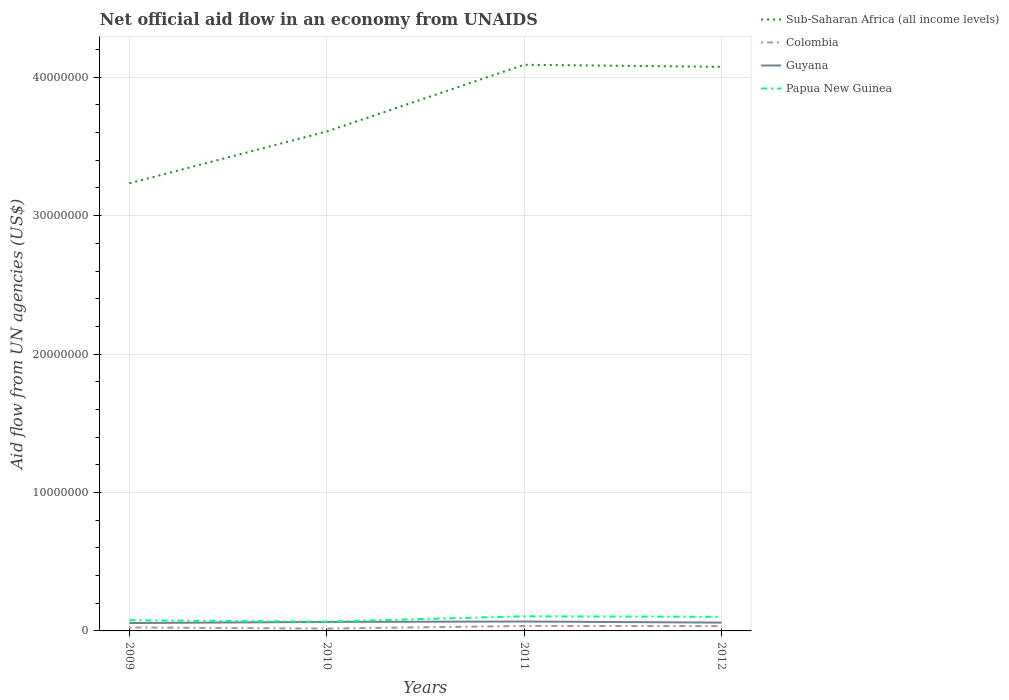Does the line corresponding to Sub-Saharan Africa (all income levels) intersect with the line corresponding to Guyana?
Offer a terse response. No. Is the number of lines equal to the number of legend labels?
Offer a very short reply. Yes. Across all years, what is the maximum net official aid flow in Guyana?
Ensure brevity in your answer.  5.70e+05. What is the total net official aid flow in Sub-Saharan Africa (all income levels) in the graph?
Your answer should be compact. 1.50e+05. What is the difference between the highest and the second highest net official aid flow in Sub-Saharan Africa (all income levels)?
Keep it short and to the point. 8.56e+06. What is the difference between the highest and the lowest net official aid flow in Colombia?
Your response must be concise. 2. Is the net official aid flow in Colombia strictly greater than the net official aid flow in Papua New Guinea over the years?
Provide a succinct answer. Yes. How many lines are there?
Provide a short and direct response. 4. How many years are there in the graph?
Provide a short and direct response. 4. Does the graph contain any zero values?
Provide a succinct answer. No. How are the legend labels stacked?
Keep it short and to the point. Vertical. What is the title of the graph?
Give a very brief answer. Net official aid flow in an economy from UNAIDS. What is the label or title of the Y-axis?
Provide a succinct answer. Aid flow from UN agencies (US$). What is the Aid flow from UN agencies (US$) in Sub-Saharan Africa (all income levels) in 2009?
Your answer should be compact. 3.23e+07. What is the Aid flow from UN agencies (US$) of Colombia in 2009?
Provide a short and direct response. 2.50e+05. What is the Aid flow from UN agencies (US$) in Guyana in 2009?
Ensure brevity in your answer.  5.70e+05. What is the Aid flow from UN agencies (US$) in Papua New Guinea in 2009?
Your answer should be compact. 7.70e+05. What is the Aid flow from UN agencies (US$) of Sub-Saharan Africa (all income levels) in 2010?
Your answer should be compact. 3.61e+07. What is the Aid flow from UN agencies (US$) of Colombia in 2010?
Your answer should be compact. 1.70e+05. What is the Aid flow from UN agencies (US$) in Guyana in 2010?
Make the answer very short. 6.50e+05. What is the Aid flow from UN agencies (US$) in Papua New Guinea in 2010?
Your answer should be very brief. 6.70e+05. What is the Aid flow from UN agencies (US$) of Sub-Saharan Africa (all income levels) in 2011?
Provide a short and direct response. 4.09e+07. What is the Aid flow from UN agencies (US$) of Colombia in 2011?
Ensure brevity in your answer.  3.60e+05. What is the Aid flow from UN agencies (US$) in Guyana in 2011?
Offer a terse response. 6.80e+05. What is the Aid flow from UN agencies (US$) of Papua New Guinea in 2011?
Give a very brief answer. 1.06e+06. What is the Aid flow from UN agencies (US$) in Sub-Saharan Africa (all income levels) in 2012?
Your answer should be compact. 4.08e+07. What is the Aid flow from UN agencies (US$) of Papua New Guinea in 2012?
Provide a short and direct response. 1.02e+06. Across all years, what is the maximum Aid flow from UN agencies (US$) in Sub-Saharan Africa (all income levels)?
Your answer should be very brief. 4.09e+07. Across all years, what is the maximum Aid flow from UN agencies (US$) in Colombia?
Your answer should be very brief. 3.60e+05. Across all years, what is the maximum Aid flow from UN agencies (US$) in Guyana?
Your answer should be compact. 6.80e+05. Across all years, what is the maximum Aid flow from UN agencies (US$) of Papua New Guinea?
Your answer should be very brief. 1.06e+06. Across all years, what is the minimum Aid flow from UN agencies (US$) in Sub-Saharan Africa (all income levels)?
Offer a very short reply. 3.23e+07. Across all years, what is the minimum Aid flow from UN agencies (US$) in Guyana?
Offer a very short reply. 5.70e+05. Across all years, what is the minimum Aid flow from UN agencies (US$) in Papua New Guinea?
Make the answer very short. 6.70e+05. What is the total Aid flow from UN agencies (US$) in Sub-Saharan Africa (all income levels) in the graph?
Keep it short and to the point. 1.50e+08. What is the total Aid flow from UN agencies (US$) of Colombia in the graph?
Provide a succinct answer. 1.13e+06. What is the total Aid flow from UN agencies (US$) in Guyana in the graph?
Offer a very short reply. 2.50e+06. What is the total Aid flow from UN agencies (US$) in Papua New Guinea in the graph?
Provide a succinct answer. 3.52e+06. What is the difference between the Aid flow from UN agencies (US$) of Sub-Saharan Africa (all income levels) in 2009 and that in 2010?
Your answer should be very brief. -3.74e+06. What is the difference between the Aid flow from UN agencies (US$) in Sub-Saharan Africa (all income levels) in 2009 and that in 2011?
Provide a succinct answer. -8.56e+06. What is the difference between the Aid flow from UN agencies (US$) of Guyana in 2009 and that in 2011?
Ensure brevity in your answer.  -1.10e+05. What is the difference between the Aid flow from UN agencies (US$) of Papua New Guinea in 2009 and that in 2011?
Your response must be concise. -2.90e+05. What is the difference between the Aid flow from UN agencies (US$) in Sub-Saharan Africa (all income levels) in 2009 and that in 2012?
Ensure brevity in your answer.  -8.41e+06. What is the difference between the Aid flow from UN agencies (US$) of Colombia in 2009 and that in 2012?
Your answer should be compact. -1.00e+05. What is the difference between the Aid flow from UN agencies (US$) of Sub-Saharan Africa (all income levels) in 2010 and that in 2011?
Your answer should be very brief. -4.82e+06. What is the difference between the Aid flow from UN agencies (US$) in Guyana in 2010 and that in 2011?
Your response must be concise. -3.00e+04. What is the difference between the Aid flow from UN agencies (US$) of Papua New Guinea in 2010 and that in 2011?
Offer a terse response. -3.90e+05. What is the difference between the Aid flow from UN agencies (US$) of Sub-Saharan Africa (all income levels) in 2010 and that in 2012?
Offer a very short reply. -4.67e+06. What is the difference between the Aid flow from UN agencies (US$) in Colombia in 2010 and that in 2012?
Keep it short and to the point. -1.80e+05. What is the difference between the Aid flow from UN agencies (US$) of Papua New Guinea in 2010 and that in 2012?
Ensure brevity in your answer.  -3.50e+05. What is the difference between the Aid flow from UN agencies (US$) in Sub-Saharan Africa (all income levels) in 2011 and that in 2012?
Your answer should be compact. 1.50e+05. What is the difference between the Aid flow from UN agencies (US$) of Colombia in 2011 and that in 2012?
Offer a terse response. 10000. What is the difference between the Aid flow from UN agencies (US$) of Papua New Guinea in 2011 and that in 2012?
Offer a very short reply. 4.00e+04. What is the difference between the Aid flow from UN agencies (US$) of Sub-Saharan Africa (all income levels) in 2009 and the Aid flow from UN agencies (US$) of Colombia in 2010?
Your answer should be compact. 3.22e+07. What is the difference between the Aid flow from UN agencies (US$) of Sub-Saharan Africa (all income levels) in 2009 and the Aid flow from UN agencies (US$) of Guyana in 2010?
Provide a succinct answer. 3.17e+07. What is the difference between the Aid flow from UN agencies (US$) in Sub-Saharan Africa (all income levels) in 2009 and the Aid flow from UN agencies (US$) in Papua New Guinea in 2010?
Offer a terse response. 3.17e+07. What is the difference between the Aid flow from UN agencies (US$) of Colombia in 2009 and the Aid flow from UN agencies (US$) of Guyana in 2010?
Your answer should be compact. -4.00e+05. What is the difference between the Aid flow from UN agencies (US$) in Colombia in 2009 and the Aid flow from UN agencies (US$) in Papua New Guinea in 2010?
Ensure brevity in your answer.  -4.20e+05. What is the difference between the Aid flow from UN agencies (US$) of Sub-Saharan Africa (all income levels) in 2009 and the Aid flow from UN agencies (US$) of Colombia in 2011?
Your response must be concise. 3.20e+07. What is the difference between the Aid flow from UN agencies (US$) in Sub-Saharan Africa (all income levels) in 2009 and the Aid flow from UN agencies (US$) in Guyana in 2011?
Provide a succinct answer. 3.17e+07. What is the difference between the Aid flow from UN agencies (US$) in Sub-Saharan Africa (all income levels) in 2009 and the Aid flow from UN agencies (US$) in Papua New Guinea in 2011?
Offer a terse response. 3.13e+07. What is the difference between the Aid flow from UN agencies (US$) in Colombia in 2009 and the Aid flow from UN agencies (US$) in Guyana in 2011?
Offer a very short reply. -4.30e+05. What is the difference between the Aid flow from UN agencies (US$) of Colombia in 2009 and the Aid flow from UN agencies (US$) of Papua New Guinea in 2011?
Your response must be concise. -8.10e+05. What is the difference between the Aid flow from UN agencies (US$) in Guyana in 2009 and the Aid flow from UN agencies (US$) in Papua New Guinea in 2011?
Ensure brevity in your answer.  -4.90e+05. What is the difference between the Aid flow from UN agencies (US$) of Sub-Saharan Africa (all income levels) in 2009 and the Aid flow from UN agencies (US$) of Colombia in 2012?
Keep it short and to the point. 3.20e+07. What is the difference between the Aid flow from UN agencies (US$) in Sub-Saharan Africa (all income levels) in 2009 and the Aid flow from UN agencies (US$) in Guyana in 2012?
Your answer should be compact. 3.17e+07. What is the difference between the Aid flow from UN agencies (US$) of Sub-Saharan Africa (all income levels) in 2009 and the Aid flow from UN agencies (US$) of Papua New Guinea in 2012?
Give a very brief answer. 3.13e+07. What is the difference between the Aid flow from UN agencies (US$) in Colombia in 2009 and the Aid flow from UN agencies (US$) in Guyana in 2012?
Offer a very short reply. -3.50e+05. What is the difference between the Aid flow from UN agencies (US$) of Colombia in 2009 and the Aid flow from UN agencies (US$) of Papua New Guinea in 2012?
Provide a succinct answer. -7.70e+05. What is the difference between the Aid flow from UN agencies (US$) of Guyana in 2009 and the Aid flow from UN agencies (US$) of Papua New Guinea in 2012?
Offer a very short reply. -4.50e+05. What is the difference between the Aid flow from UN agencies (US$) in Sub-Saharan Africa (all income levels) in 2010 and the Aid flow from UN agencies (US$) in Colombia in 2011?
Provide a succinct answer. 3.57e+07. What is the difference between the Aid flow from UN agencies (US$) in Sub-Saharan Africa (all income levels) in 2010 and the Aid flow from UN agencies (US$) in Guyana in 2011?
Offer a terse response. 3.54e+07. What is the difference between the Aid flow from UN agencies (US$) of Sub-Saharan Africa (all income levels) in 2010 and the Aid flow from UN agencies (US$) of Papua New Guinea in 2011?
Provide a short and direct response. 3.50e+07. What is the difference between the Aid flow from UN agencies (US$) in Colombia in 2010 and the Aid flow from UN agencies (US$) in Guyana in 2011?
Make the answer very short. -5.10e+05. What is the difference between the Aid flow from UN agencies (US$) of Colombia in 2010 and the Aid flow from UN agencies (US$) of Papua New Guinea in 2011?
Provide a succinct answer. -8.90e+05. What is the difference between the Aid flow from UN agencies (US$) of Guyana in 2010 and the Aid flow from UN agencies (US$) of Papua New Guinea in 2011?
Make the answer very short. -4.10e+05. What is the difference between the Aid flow from UN agencies (US$) of Sub-Saharan Africa (all income levels) in 2010 and the Aid flow from UN agencies (US$) of Colombia in 2012?
Your answer should be very brief. 3.57e+07. What is the difference between the Aid flow from UN agencies (US$) in Sub-Saharan Africa (all income levels) in 2010 and the Aid flow from UN agencies (US$) in Guyana in 2012?
Your answer should be very brief. 3.55e+07. What is the difference between the Aid flow from UN agencies (US$) in Sub-Saharan Africa (all income levels) in 2010 and the Aid flow from UN agencies (US$) in Papua New Guinea in 2012?
Ensure brevity in your answer.  3.51e+07. What is the difference between the Aid flow from UN agencies (US$) in Colombia in 2010 and the Aid flow from UN agencies (US$) in Guyana in 2012?
Your answer should be very brief. -4.30e+05. What is the difference between the Aid flow from UN agencies (US$) in Colombia in 2010 and the Aid flow from UN agencies (US$) in Papua New Guinea in 2012?
Keep it short and to the point. -8.50e+05. What is the difference between the Aid flow from UN agencies (US$) of Guyana in 2010 and the Aid flow from UN agencies (US$) of Papua New Guinea in 2012?
Keep it short and to the point. -3.70e+05. What is the difference between the Aid flow from UN agencies (US$) of Sub-Saharan Africa (all income levels) in 2011 and the Aid flow from UN agencies (US$) of Colombia in 2012?
Offer a very short reply. 4.06e+07. What is the difference between the Aid flow from UN agencies (US$) in Sub-Saharan Africa (all income levels) in 2011 and the Aid flow from UN agencies (US$) in Guyana in 2012?
Provide a succinct answer. 4.03e+07. What is the difference between the Aid flow from UN agencies (US$) of Sub-Saharan Africa (all income levels) in 2011 and the Aid flow from UN agencies (US$) of Papua New Guinea in 2012?
Provide a succinct answer. 3.99e+07. What is the difference between the Aid flow from UN agencies (US$) of Colombia in 2011 and the Aid flow from UN agencies (US$) of Papua New Guinea in 2012?
Provide a succinct answer. -6.60e+05. What is the average Aid flow from UN agencies (US$) of Sub-Saharan Africa (all income levels) per year?
Offer a terse response. 3.75e+07. What is the average Aid flow from UN agencies (US$) in Colombia per year?
Your answer should be very brief. 2.82e+05. What is the average Aid flow from UN agencies (US$) in Guyana per year?
Your response must be concise. 6.25e+05. What is the average Aid flow from UN agencies (US$) of Papua New Guinea per year?
Offer a terse response. 8.80e+05. In the year 2009, what is the difference between the Aid flow from UN agencies (US$) of Sub-Saharan Africa (all income levels) and Aid flow from UN agencies (US$) of Colombia?
Your answer should be very brief. 3.21e+07. In the year 2009, what is the difference between the Aid flow from UN agencies (US$) in Sub-Saharan Africa (all income levels) and Aid flow from UN agencies (US$) in Guyana?
Keep it short and to the point. 3.18e+07. In the year 2009, what is the difference between the Aid flow from UN agencies (US$) of Sub-Saharan Africa (all income levels) and Aid flow from UN agencies (US$) of Papua New Guinea?
Make the answer very short. 3.16e+07. In the year 2009, what is the difference between the Aid flow from UN agencies (US$) in Colombia and Aid flow from UN agencies (US$) in Guyana?
Give a very brief answer. -3.20e+05. In the year 2009, what is the difference between the Aid flow from UN agencies (US$) in Colombia and Aid flow from UN agencies (US$) in Papua New Guinea?
Make the answer very short. -5.20e+05. In the year 2010, what is the difference between the Aid flow from UN agencies (US$) in Sub-Saharan Africa (all income levels) and Aid flow from UN agencies (US$) in Colombia?
Offer a very short reply. 3.59e+07. In the year 2010, what is the difference between the Aid flow from UN agencies (US$) in Sub-Saharan Africa (all income levels) and Aid flow from UN agencies (US$) in Guyana?
Provide a short and direct response. 3.54e+07. In the year 2010, what is the difference between the Aid flow from UN agencies (US$) of Sub-Saharan Africa (all income levels) and Aid flow from UN agencies (US$) of Papua New Guinea?
Your answer should be very brief. 3.54e+07. In the year 2010, what is the difference between the Aid flow from UN agencies (US$) in Colombia and Aid flow from UN agencies (US$) in Guyana?
Make the answer very short. -4.80e+05. In the year 2010, what is the difference between the Aid flow from UN agencies (US$) of Colombia and Aid flow from UN agencies (US$) of Papua New Guinea?
Your answer should be very brief. -5.00e+05. In the year 2011, what is the difference between the Aid flow from UN agencies (US$) of Sub-Saharan Africa (all income levels) and Aid flow from UN agencies (US$) of Colombia?
Make the answer very short. 4.05e+07. In the year 2011, what is the difference between the Aid flow from UN agencies (US$) in Sub-Saharan Africa (all income levels) and Aid flow from UN agencies (US$) in Guyana?
Ensure brevity in your answer.  4.02e+07. In the year 2011, what is the difference between the Aid flow from UN agencies (US$) of Sub-Saharan Africa (all income levels) and Aid flow from UN agencies (US$) of Papua New Guinea?
Offer a very short reply. 3.98e+07. In the year 2011, what is the difference between the Aid flow from UN agencies (US$) of Colombia and Aid flow from UN agencies (US$) of Guyana?
Ensure brevity in your answer.  -3.20e+05. In the year 2011, what is the difference between the Aid flow from UN agencies (US$) in Colombia and Aid flow from UN agencies (US$) in Papua New Guinea?
Your answer should be compact. -7.00e+05. In the year 2011, what is the difference between the Aid flow from UN agencies (US$) in Guyana and Aid flow from UN agencies (US$) in Papua New Guinea?
Provide a succinct answer. -3.80e+05. In the year 2012, what is the difference between the Aid flow from UN agencies (US$) of Sub-Saharan Africa (all income levels) and Aid flow from UN agencies (US$) of Colombia?
Ensure brevity in your answer.  4.04e+07. In the year 2012, what is the difference between the Aid flow from UN agencies (US$) in Sub-Saharan Africa (all income levels) and Aid flow from UN agencies (US$) in Guyana?
Make the answer very short. 4.02e+07. In the year 2012, what is the difference between the Aid flow from UN agencies (US$) of Sub-Saharan Africa (all income levels) and Aid flow from UN agencies (US$) of Papua New Guinea?
Offer a very short reply. 3.97e+07. In the year 2012, what is the difference between the Aid flow from UN agencies (US$) of Colombia and Aid flow from UN agencies (US$) of Papua New Guinea?
Ensure brevity in your answer.  -6.70e+05. In the year 2012, what is the difference between the Aid flow from UN agencies (US$) of Guyana and Aid flow from UN agencies (US$) of Papua New Guinea?
Your response must be concise. -4.20e+05. What is the ratio of the Aid flow from UN agencies (US$) of Sub-Saharan Africa (all income levels) in 2009 to that in 2010?
Give a very brief answer. 0.9. What is the ratio of the Aid flow from UN agencies (US$) in Colombia in 2009 to that in 2010?
Give a very brief answer. 1.47. What is the ratio of the Aid flow from UN agencies (US$) of Guyana in 2009 to that in 2010?
Provide a succinct answer. 0.88. What is the ratio of the Aid flow from UN agencies (US$) of Papua New Guinea in 2009 to that in 2010?
Provide a short and direct response. 1.15. What is the ratio of the Aid flow from UN agencies (US$) in Sub-Saharan Africa (all income levels) in 2009 to that in 2011?
Offer a terse response. 0.79. What is the ratio of the Aid flow from UN agencies (US$) in Colombia in 2009 to that in 2011?
Your answer should be compact. 0.69. What is the ratio of the Aid flow from UN agencies (US$) of Guyana in 2009 to that in 2011?
Keep it short and to the point. 0.84. What is the ratio of the Aid flow from UN agencies (US$) of Papua New Guinea in 2009 to that in 2011?
Provide a succinct answer. 0.73. What is the ratio of the Aid flow from UN agencies (US$) of Sub-Saharan Africa (all income levels) in 2009 to that in 2012?
Give a very brief answer. 0.79. What is the ratio of the Aid flow from UN agencies (US$) of Papua New Guinea in 2009 to that in 2012?
Ensure brevity in your answer.  0.75. What is the ratio of the Aid flow from UN agencies (US$) of Sub-Saharan Africa (all income levels) in 2010 to that in 2011?
Keep it short and to the point. 0.88. What is the ratio of the Aid flow from UN agencies (US$) in Colombia in 2010 to that in 2011?
Offer a very short reply. 0.47. What is the ratio of the Aid flow from UN agencies (US$) of Guyana in 2010 to that in 2011?
Keep it short and to the point. 0.96. What is the ratio of the Aid flow from UN agencies (US$) of Papua New Guinea in 2010 to that in 2011?
Give a very brief answer. 0.63. What is the ratio of the Aid flow from UN agencies (US$) in Sub-Saharan Africa (all income levels) in 2010 to that in 2012?
Provide a short and direct response. 0.89. What is the ratio of the Aid flow from UN agencies (US$) in Colombia in 2010 to that in 2012?
Your answer should be very brief. 0.49. What is the ratio of the Aid flow from UN agencies (US$) in Guyana in 2010 to that in 2012?
Offer a very short reply. 1.08. What is the ratio of the Aid flow from UN agencies (US$) of Papua New Guinea in 2010 to that in 2012?
Offer a very short reply. 0.66. What is the ratio of the Aid flow from UN agencies (US$) in Sub-Saharan Africa (all income levels) in 2011 to that in 2012?
Provide a succinct answer. 1. What is the ratio of the Aid flow from UN agencies (US$) of Colombia in 2011 to that in 2012?
Ensure brevity in your answer.  1.03. What is the ratio of the Aid flow from UN agencies (US$) of Guyana in 2011 to that in 2012?
Your response must be concise. 1.13. What is the ratio of the Aid flow from UN agencies (US$) in Papua New Guinea in 2011 to that in 2012?
Keep it short and to the point. 1.04. What is the difference between the highest and the second highest Aid flow from UN agencies (US$) of Colombia?
Provide a short and direct response. 10000. What is the difference between the highest and the second highest Aid flow from UN agencies (US$) in Guyana?
Give a very brief answer. 3.00e+04. What is the difference between the highest and the lowest Aid flow from UN agencies (US$) in Sub-Saharan Africa (all income levels)?
Make the answer very short. 8.56e+06. What is the difference between the highest and the lowest Aid flow from UN agencies (US$) of Guyana?
Keep it short and to the point. 1.10e+05. What is the difference between the highest and the lowest Aid flow from UN agencies (US$) of Papua New Guinea?
Provide a short and direct response. 3.90e+05. 